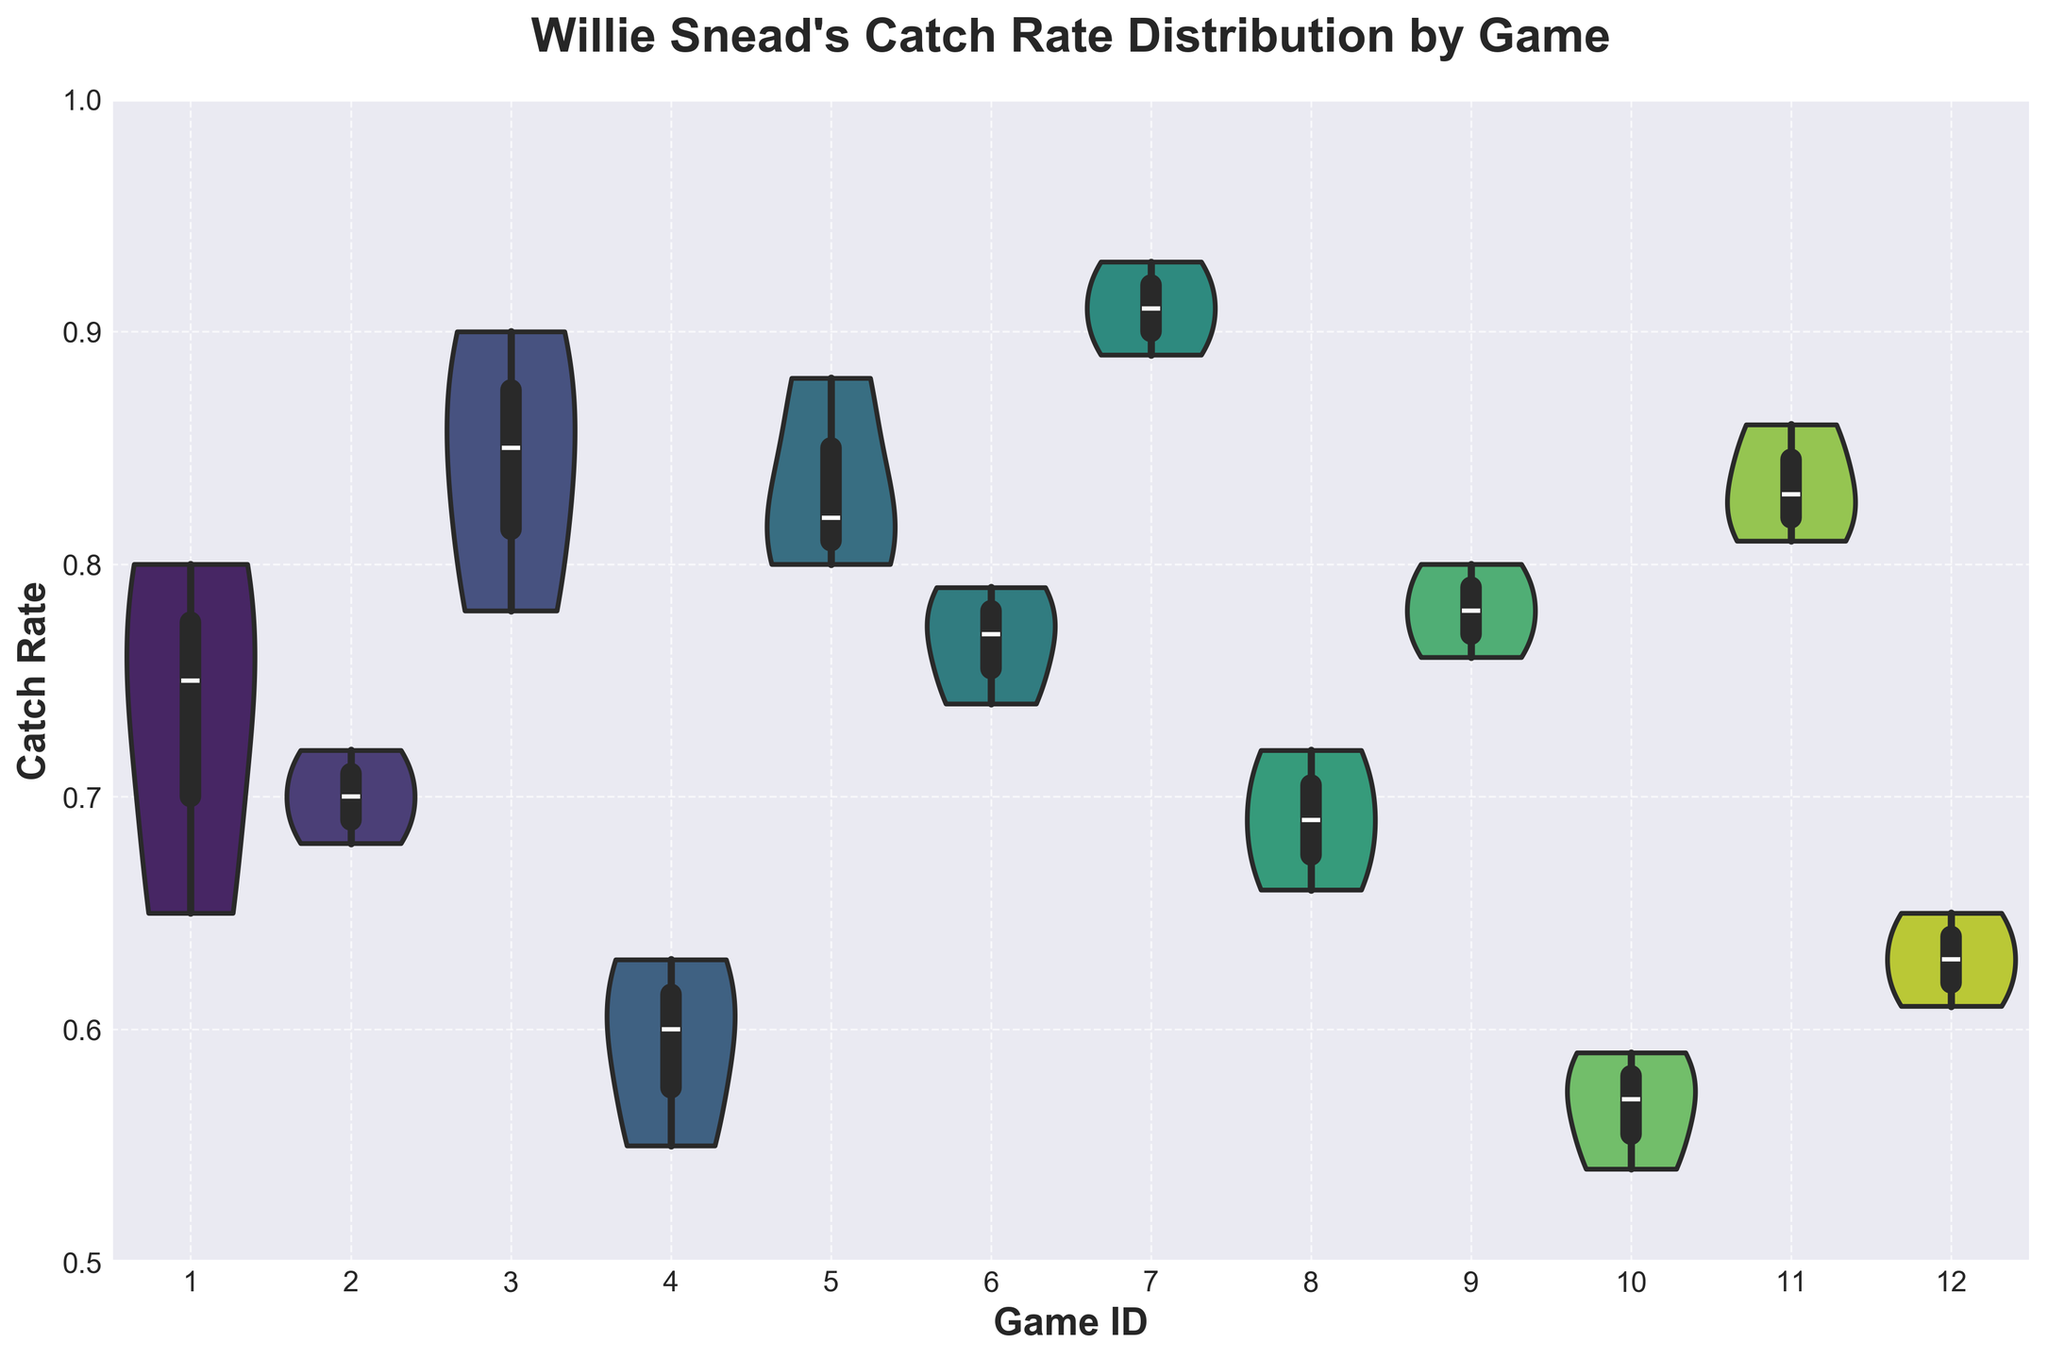What is the title of the plot? The title is located at the top of the chart and is in a bold font.
Answer: Willie Snead's Catch Rate Distribution by Game What is the range of the y-axis? The y-axis range is defined by the starting and ending tick marks.
Answer: 0.5 to 1.0 Which game has the highest median catch rate? To find the game with the highest median catch rate, we look for the median line inside the box plot that is positioned highest on the y-axis.
Answer: Game 7 How many ticks are there on the y-axis? Count the number of y-axis labels that appear between 0.5 and 1.0.
Answer: 6 Which games have a catch rate distribution that includes values below 0.6? For this, we need to identify the games where the bottom of the violin plot dips below 0.6.
Answer: Game 4, Game 10, Game 12 Which game has the widest catch rate distribution? The game with the widest distribution will have the thickest violin plot.
Answer: Game 10 How does the median catch rate of Game 9 compare to that of Game 8? Look at the position of the median lines in the box plots for both games. Determine which one is higher or if they are equal.
Answer: Higher What is the median catch rate for Game 1? Identify the horizontal line inside the box plot for Game 1.
Answer: 0.75 What is the catch rate distribution shape for Game 3? Observe the shape of the violin plot for Game 3, whether it is symmetric or skewed, and describe it.
Answer: Symmetric In which game do we see the smallest range between the upper and lower quartiles of the catch rate? Look for the box plot with the shortest height between the top and bottom edges of the box.
Answer: Game 11 